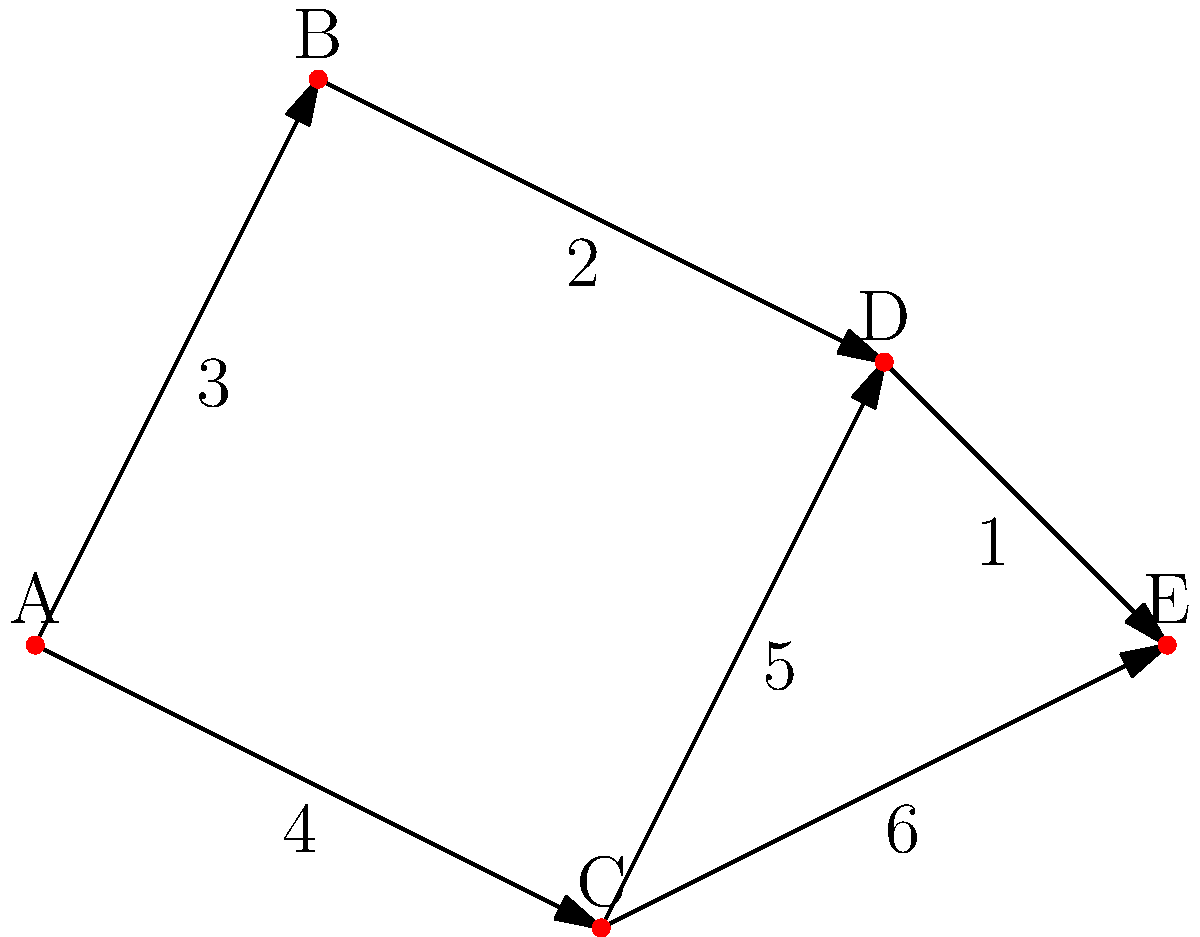A local charity organization is planning a fundraising road trip. They want to travel from city A to city E while visiting as few cities as possible to minimize fuel costs. Given the road network map above, where each number represents the distance between cities in hours, what is the shortest travel time from city A to city E? To find the shortest path from A to E, we'll use Dijkstra's algorithm:

1. Initialize:
   - Distance to A: 0
   - Distance to all other cities: infinity

2. From A, we can reach:
   - B with distance 3
   - C with distance 4

3. Choose B (shortest known distance). From B:
   - Can reach D with total distance 3 + 2 = 5

4. Choose C. From C:
   - Can reach D with total distance 4 + 5 = 9 (longer than current, ignore)
   - Can reach E with total distance 4 + 6 = 10

5. Choose D (from B). From D:
   - Can reach E with total distance 5 + 1 = 6

6. The shortest path is A -> B -> D -> E with a total travel time of 6 hours.

This route minimizes both the number of cities visited and the total travel time, aligning with the charity's goal of minimizing fuel costs.
Answer: 6 hours 